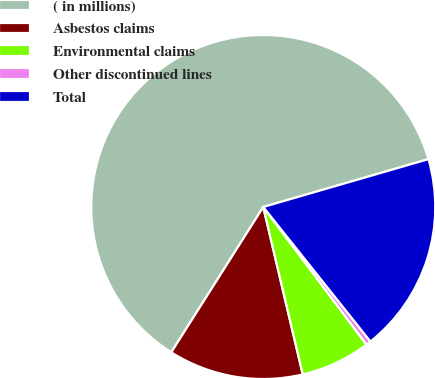Convert chart to OTSL. <chart><loc_0><loc_0><loc_500><loc_500><pie_chart><fcel>( in millions)<fcel>Asbestos claims<fcel>Environmental claims<fcel>Other discontinued lines<fcel>Total<nl><fcel>61.53%<fcel>12.67%<fcel>6.56%<fcel>0.46%<fcel>18.78%<nl></chart> 